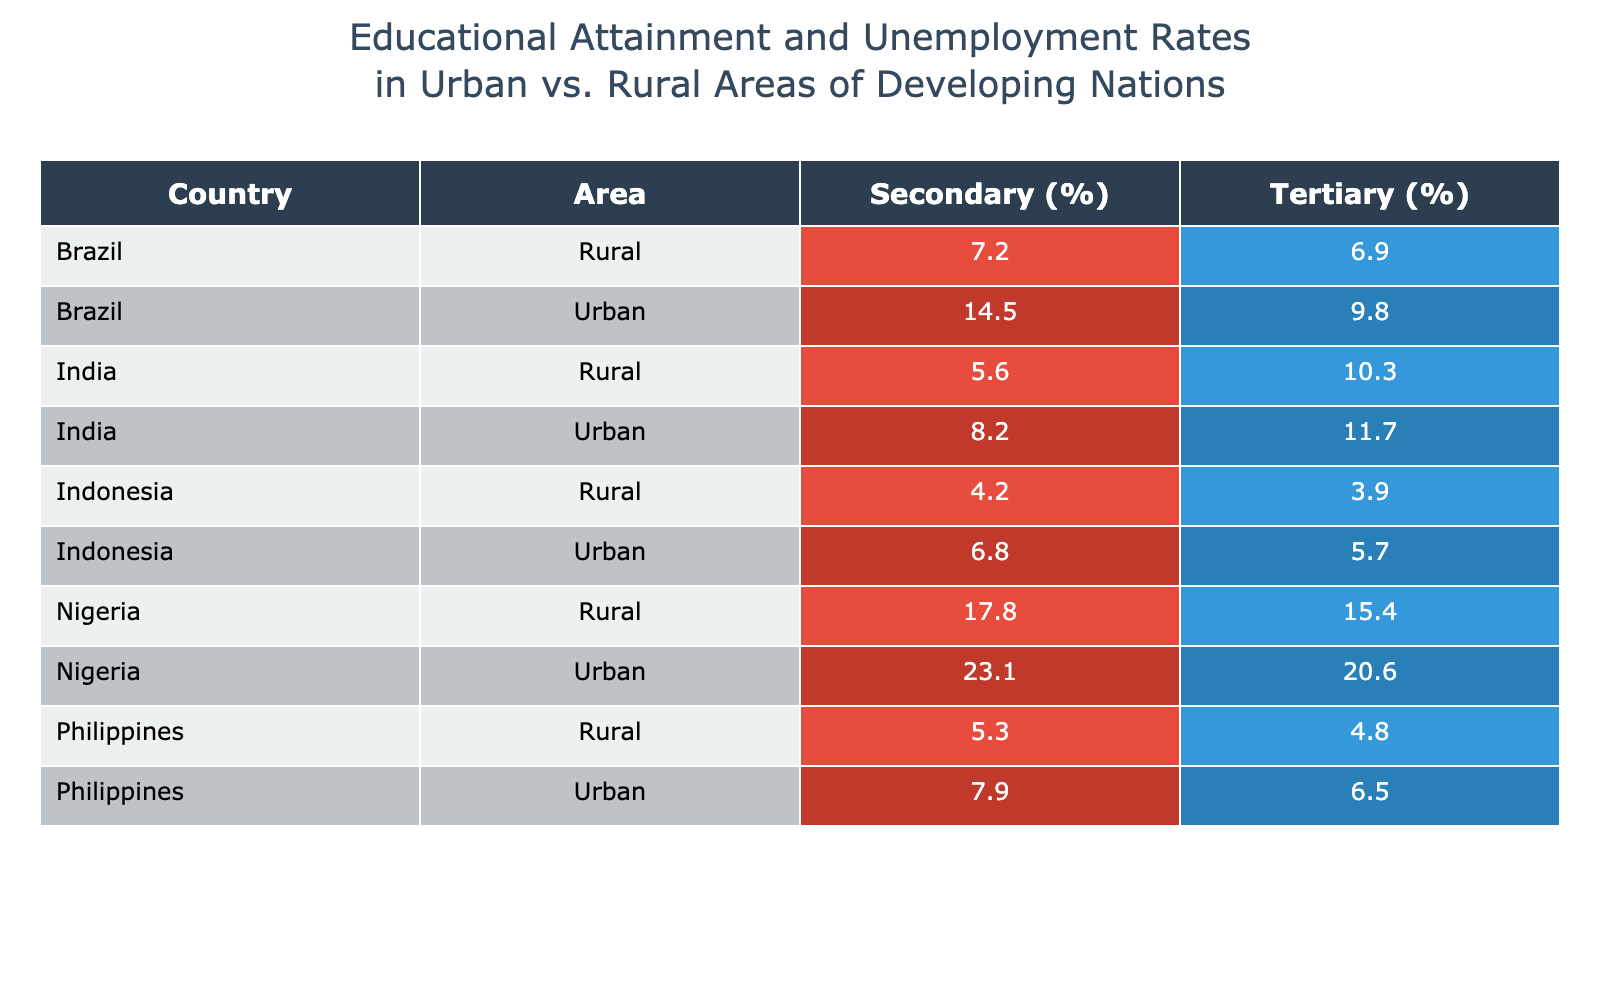What is the unemployment rate for urban secondary education in India? The table shows that the unemployment rate for urban secondary education in India is listed under the "Urban" area for "Secondary" education. Hence, we directly refer to the value in that cell.
Answer: 8.2 Which area in Brazil has a higher unemployment rate for tertiary education? By examining the table, we compare the unemployment rates for "Tertiary" education in both urban and rural areas of Brazil. The urban rate is 9.8, while the rural rate is 6.9. Urban has a higher rate.
Answer: Urban What is the difference in unemployment rates for rural secondary education in Nigeria and Brazil? In Nigeria, the unemployment rate for rural secondary education is 17.8, while in Brazil, it is 7.2. To find the difference, we subtract Brazil's rate from Nigeria's: 17.8 - 7.2 = 10.6.
Answer: 10.6 True or False: The unemployment rate for tertiary education is higher in urban areas than rural areas in all countries listed. By analyzing the table, we can evaluate each country's rates. For instance, India, Brazil, and Nigeria have higher urban rates for tertiary education. However, Indonesia shows a lower urban rate (5.7) compared to rural (3.9), and Philippines also shows lower urban (6.5) vs. rural (4.8) for tertiary. Thus, the statement is false.
Answer: False What is the average unemployment rate for secondary education across all urban areas? We gather the unemployment rates for secondary education in urban areas from all countries: India (8.2), Brazil (14.5), Nigeria (23.1), Indonesia (6.8), and Philippines (7.9). We sum these values, which leads to 8.2 + 14.5 + 23.1 + 6.8 + 7.9 = 60.5. Then we divide by the number of data points (5) to find the average: 60.5 / 5 = 12.1.
Answer: 12.1 